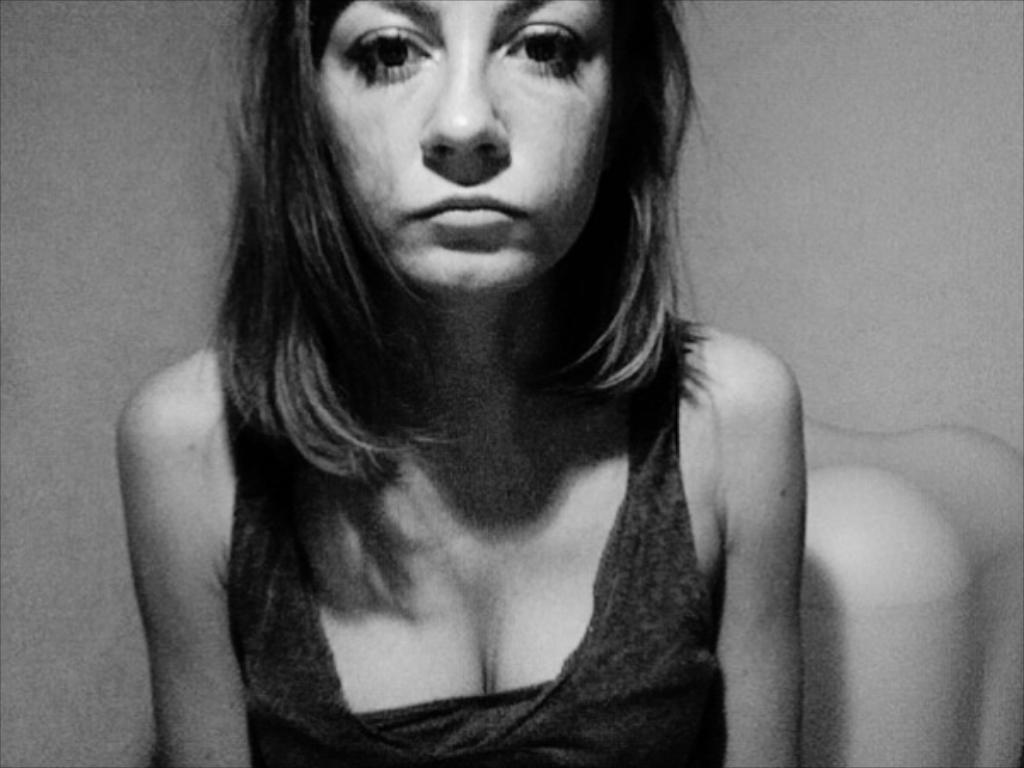What is the main subject of the image? There is a woman in the image. Can you describe the background of the image? There may be a wall behind the woman. What type of yarn is the woman using on the stage in the image? There is no yarn or stage present in the image; it only features a woman and possibly a wall in the background. 